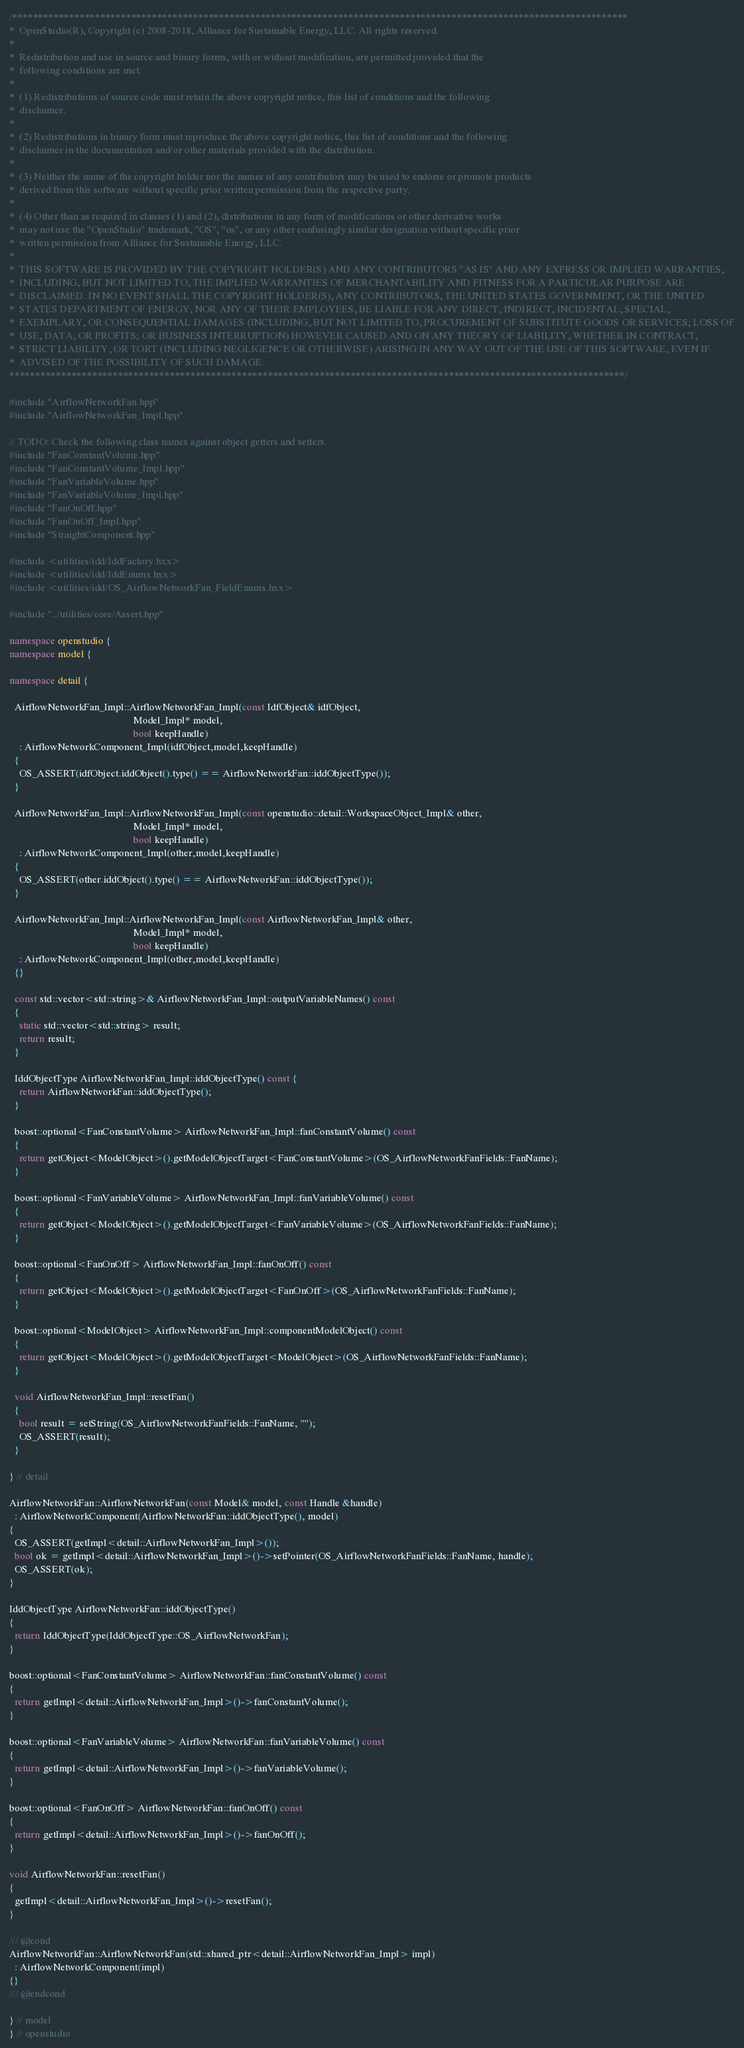Convert code to text. <code><loc_0><loc_0><loc_500><loc_500><_C++_>/***********************************************************************************************************************
*  OpenStudio(R), Copyright (c) 2008-2018, Alliance for Sustainable Energy, LLC. All rights reserved.
*
*  Redistribution and use in source and binary forms, with or without modification, are permitted provided that the
*  following conditions are met:
*
*  (1) Redistributions of source code must retain the above copyright notice, this list of conditions and the following
*  disclaimer.
*
*  (2) Redistributions in binary form must reproduce the above copyright notice, this list of conditions and the following
*  disclaimer in the documentation and/or other materials provided with the distribution.
*
*  (3) Neither the name of the copyright holder nor the names of any contributors may be used to endorse or promote products
*  derived from this software without specific prior written permission from the respective party.
*
*  (4) Other than as required in clauses (1) and (2), distributions in any form of modifications or other derivative works
*  may not use the "OpenStudio" trademark, "OS", "os", or any other confusingly similar designation without specific prior
*  written permission from Alliance for Sustainable Energy, LLC.
*
*  THIS SOFTWARE IS PROVIDED BY THE COPYRIGHT HOLDER(S) AND ANY CONTRIBUTORS "AS IS" AND ANY EXPRESS OR IMPLIED WARRANTIES,
*  INCLUDING, BUT NOT LIMITED TO, THE IMPLIED WARRANTIES OF MERCHANTABILITY AND FITNESS FOR A PARTICULAR PURPOSE ARE
*  DISCLAIMED. IN NO EVENT SHALL THE COPYRIGHT HOLDER(S), ANY CONTRIBUTORS, THE UNITED STATES GOVERNMENT, OR THE UNITED
*  STATES DEPARTMENT OF ENERGY, NOR ANY OF THEIR EMPLOYEES, BE LIABLE FOR ANY DIRECT, INDIRECT, INCIDENTAL, SPECIAL,
*  EXEMPLARY, OR CONSEQUENTIAL DAMAGES (INCLUDING, BUT NOT LIMITED TO, PROCUREMENT OF SUBSTITUTE GOODS OR SERVICES; LOSS OF
*  USE, DATA, OR PROFITS; OR BUSINESS INTERRUPTION) HOWEVER CAUSED AND ON ANY THEORY OF LIABILITY, WHETHER IN CONTRACT,
*  STRICT LIABILITY, OR TORT (INCLUDING NEGLIGENCE OR OTHERWISE) ARISING IN ANY WAY OUT OF THE USE OF THIS SOFTWARE, EVEN IF
*  ADVISED OF THE POSSIBILITY OF SUCH DAMAGE.
***********************************************************************************************************************/

#include "AirflowNetworkFan.hpp"
#include "AirflowNetworkFan_Impl.hpp"

// TODO: Check the following class names against object getters and setters.
#include "FanConstantVolume.hpp"
#include "FanConstantVolume_Impl.hpp"
#include "FanVariableVolume.hpp"
#include "FanVariableVolume_Impl.hpp"
#include "FanOnOff.hpp"
#include "FanOnOff_Impl.hpp"
#include "StraightComponent.hpp"

#include <utilities/idd/IddFactory.hxx>
#include <utilities/idd/IddEnums.hxx>
#include <utilities/idd/OS_AirflowNetworkFan_FieldEnums.hxx>

#include "../utilities/core/Assert.hpp"

namespace openstudio {
namespace model {

namespace detail {

  AirflowNetworkFan_Impl::AirflowNetworkFan_Impl(const IdfObject& idfObject,
                                                 Model_Impl* model,
                                                 bool keepHandle)
    : AirflowNetworkComponent_Impl(idfObject,model,keepHandle)
  {
    OS_ASSERT(idfObject.iddObject().type() == AirflowNetworkFan::iddObjectType());
  }

  AirflowNetworkFan_Impl::AirflowNetworkFan_Impl(const openstudio::detail::WorkspaceObject_Impl& other,
                                                 Model_Impl* model,
                                                 bool keepHandle)
    : AirflowNetworkComponent_Impl(other,model,keepHandle)
  {
    OS_ASSERT(other.iddObject().type() == AirflowNetworkFan::iddObjectType());
  }

  AirflowNetworkFan_Impl::AirflowNetworkFan_Impl(const AirflowNetworkFan_Impl& other,
                                                 Model_Impl* model,
                                                 bool keepHandle)
    : AirflowNetworkComponent_Impl(other,model,keepHandle)
  {}

  const std::vector<std::string>& AirflowNetworkFan_Impl::outputVariableNames() const
  {
    static std::vector<std::string> result;
    return result;
  }

  IddObjectType AirflowNetworkFan_Impl::iddObjectType() const {
    return AirflowNetworkFan::iddObjectType();
  }

  boost::optional<FanConstantVolume> AirflowNetworkFan_Impl::fanConstantVolume() const
  {
    return getObject<ModelObject>().getModelObjectTarget<FanConstantVolume>(OS_AirflowNetworkFanFields::FanName);
  }

  boost::optional<FanVariableVolume> AirflowNetworkFan_Impl::fanVariableVolume() const
  {
    return getObject<ModelObject>().getModelObjectTarget<FanVariableVolume>(OS_AirflowNetworkFanFields::FanName);
  }

  boost::optional<FanOnOff> AirflowNetworkFan_Impl::fanOnOff() const
  {
    return getObject<ModelObject>().getModelObjectTarget<FanOnOff>(OS_AirflowNetworkFanFields::FanName);
  }

  boost::optional<ModelObject> AirflowNetworkFan_Impl::componentModelObject() const
  {
    return getObject<ModelObject>().getModelObjectTarget<ModelObject>(OS_AirflowNetworkFanFields::FanName);
  }

  void AirflowNetworkFan_Impl::resetFan()
  {
    bool result = setString(OS_AirflowNetworkFanFields::FanName, "");
    OS_ASSERT(result);
  }

} // detail

AirflowNetworkFan::AirflowNetworkFan(const Model& model, const Handle &handle)
  : AirflowNetworkComponent(AirflowNetworkFan::iddObjectType(), model)
{
  OS_ASSERT(getImpl<detail::AirflowNetworkFan_Impl>());
  bool ok = getImpl<detail::AirflowNetworkFan_Impl>()->setPointer(OS_AirflowNetworkFanFields::FanName, handle);
  OS_ASSERT(ok);
}

IddObjectType AirflowNetworkFan::iddObjectType()
{
  return IddObjectType(IddObjectType::OS_AirflowNetworkFan);
}

boost::optional<FanConstantVolume> AirflowNetworkFan::fanConstantVolume() const
{
  return getImpl<detail::AirflowNetworkFan_Impl>()->fanConstantVolume();
}

boost::optional<FanVariableVolume> AirflowNetworkFan::fanVariableVolume() const
{
  return getImpl<detail::AirflowNetworkFan_Impl>()->fanVariableVolume();
}

boost::optional<FanOnOff> AirflowNetworkFan::fanOnOff() const
{
  return getImpl<detail::AirflowNetworkFan_Impl>()->fanOnOff();
}

void AirflowNetworkFan::resetFan()
{
  getImpl<detail::AirflowNetworkFan_Impl>()->resetFan();
}

/// @cond
AirflowNetworkFan::AirflowNetworkFan(std::shared_ptr<detail::AirflowNetworkFan_Impl> impl)
  : AirflowNetworkComponent(impl)
{}
/// @endcond

} // model
} // openstudio

</code> 